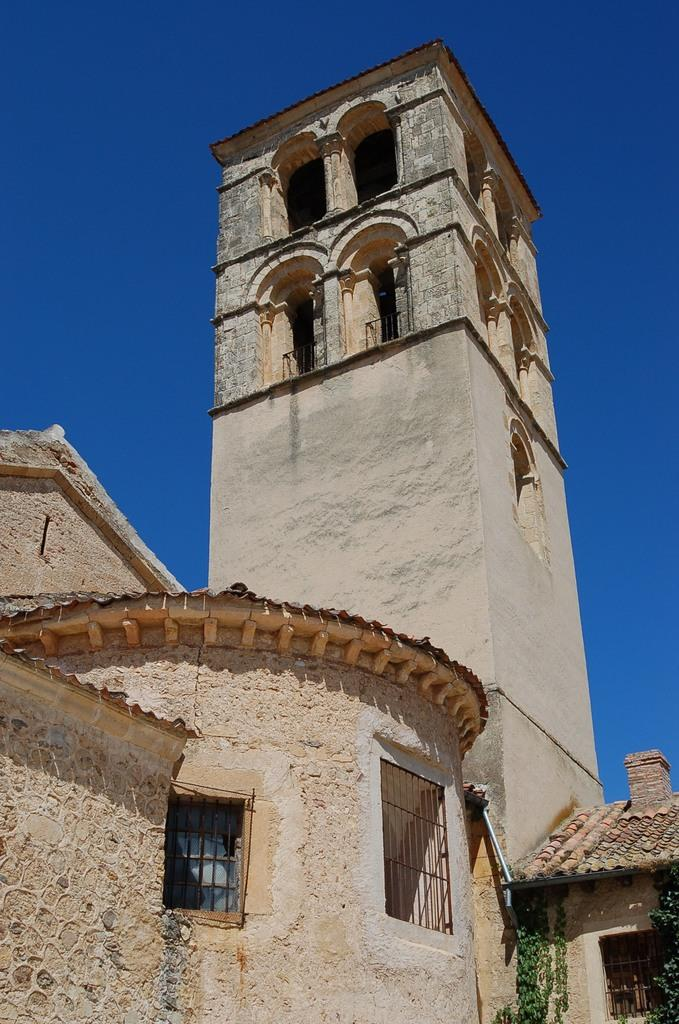What type of structure is present in the image? There is a building in the image. What features can be observed on the building? The building has windows and a roof. What can be seen in the background of the image? The sky is visible in the image, and it is blue. Where is the kitten using the rake in the image? There is no kitten or rake present in the image. What type of bat is flying in the sky in the image? There are no bats present in the image; the sky is blue with no visible animals. 